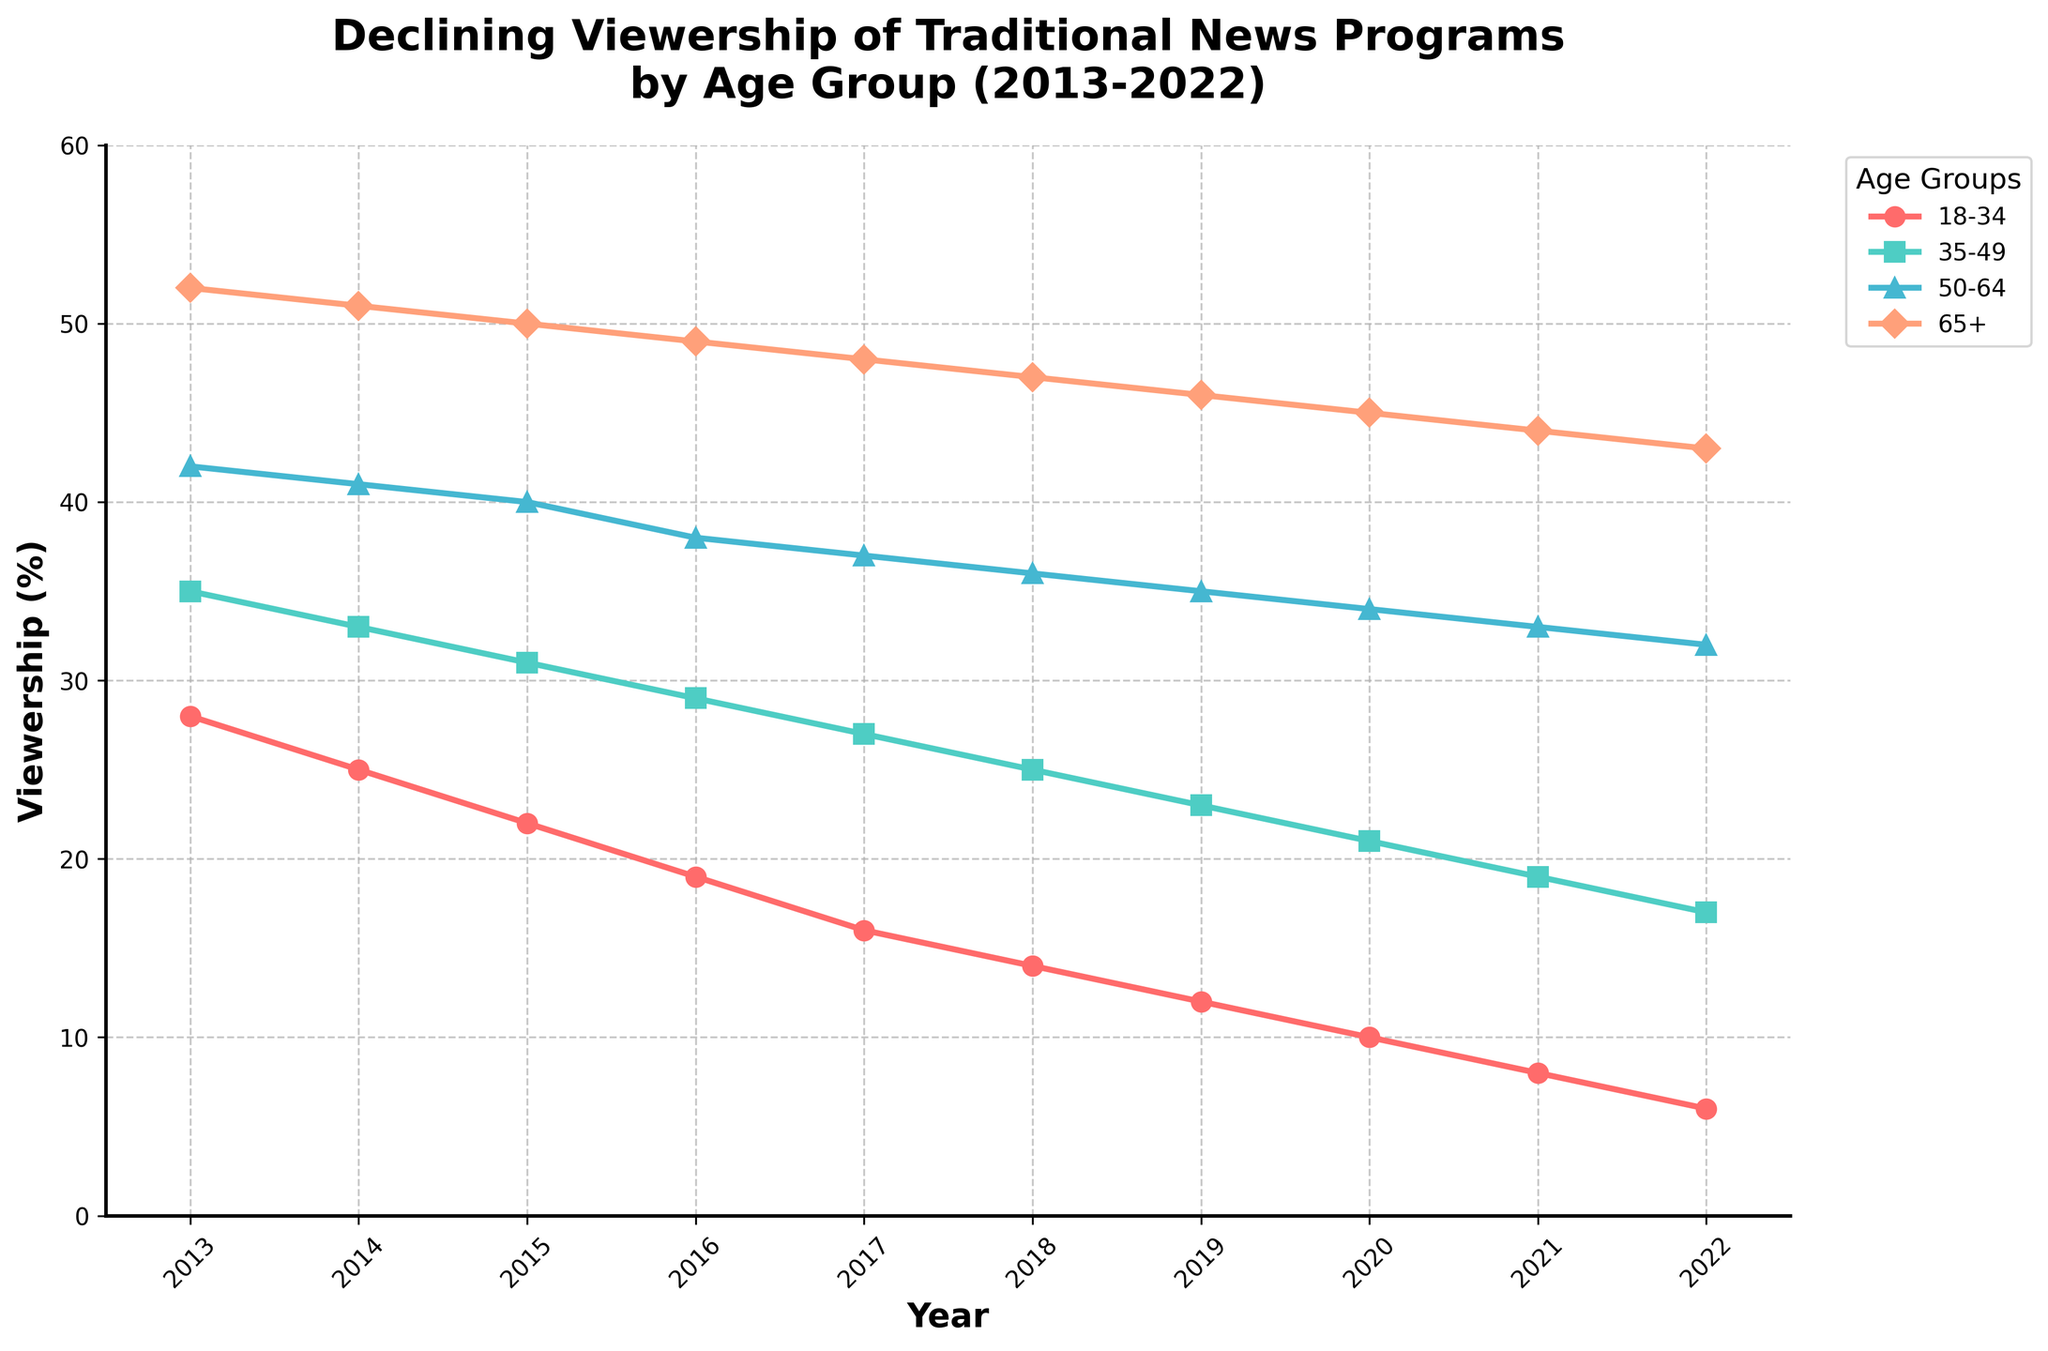Which age group has the lowest viewership in 2022? Look for the age group with the smallest value on the rightmost side of the chart (year 2022). The group 18-34 has the lowest viewership in 2022.
Answer: 18-34 Between which years did the 35-49 age group's viewership drop the most? Identify the two consecutive years where the decrease in viewership for the 35-49 age group is the greatest by comparing the numerical differences year by year. From 2013 to 2014, the viewership drops by 2 (from 35% to 33%); from 2014 to 2015, it also drops by 2 (from 33% to 31%) and so on. The year with the greatest drop is from 2016 to 2017, dropping by 2% (from 29% to 27%).
Answer: 2016-2017 What is the average viewership of the 65+ age group over the decade? Sum the values of the 65+ group from 2013 to 2022 and then divide by the number of years (10). The sum is 52 + 51 + 50 + 49 + 48 + 47 + 46 + 45 + 44 + 43 = 475. Divide 475 by 10 gives an average of 47.5%.
Answer: 47.5% Which age group shows the most consistent decline over the period? Examine the slopes of each age group's line on the chart for consistency. All age groups decline, but the 65+ line shows a more uniform decline without steep drops, indicating the most consistent trend.
Answer: 65+ How much did the viewership for the 18-34 age group decline from 2013 to 2022? Subtract the viewership percentage for the 18-34 group in 2022 from that in 2013 (28% - 6% = 22%).
Answer: 22% In 2019, how much higher was the viewership for the 50-64 age group compared to the 18-34 age group? Find the values for both age groups in 2019 and subtract the value for the 18-34 group from that of the 50-64 group (35% - 12% = 23%).
Answer: 23% What trend do you see for the viewership among the 50-64 age group? Identify the slope for the 50-64 age group from 2013 to 2022. The viewership shows a consistent downward trend from 42% in 2013 to 32% in 2022.
Answer: Consistent decline Which age group had the smallest rate of decline in viewership between 2017 and 2018? Calculate the difference in viewership for each age group between 2017 and 2018. The differences are 2% (18-34), 2% (35-49), 1% (50-64), and 1% (65+). Both the 50-64 and 65+ groups show the smallest rate of decline with 1%.
Answer: 50-64 and 65+ How did the viewership of the 35-49 age group change from 2015 to 2019? Identify the values for 2015 and 2019 for the 35-49 age group (31% and 23%, respectively) and calculate the difference (31% - 23% = 8%).
Answer: Declined by 8% In which year did the 50-64 age group cross below 40% viewership? Look for the first year where the viewership percentage for the 50-64 age group drops below 40%. This happens in 2015 where the viewership is 40%, and the next year, it is below 40%.
Answer: 2016 